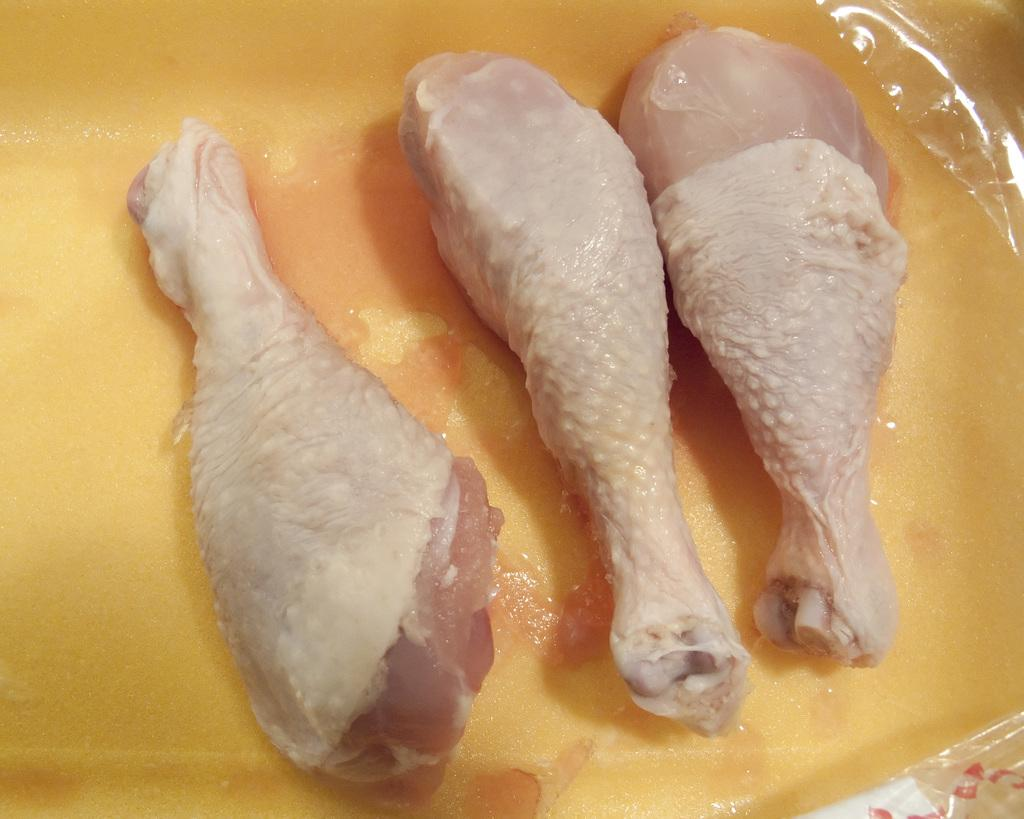What type of food is shown in the image? There are three chicken drumsticks in the image. How are the chicken drumsticks stored or contained? The chicken drumsticks are in a yellow color container. Is there a woman reading a book in the image? No, there is no woman or book present in the image; it only features chicken drumsticks in a yellow container. 